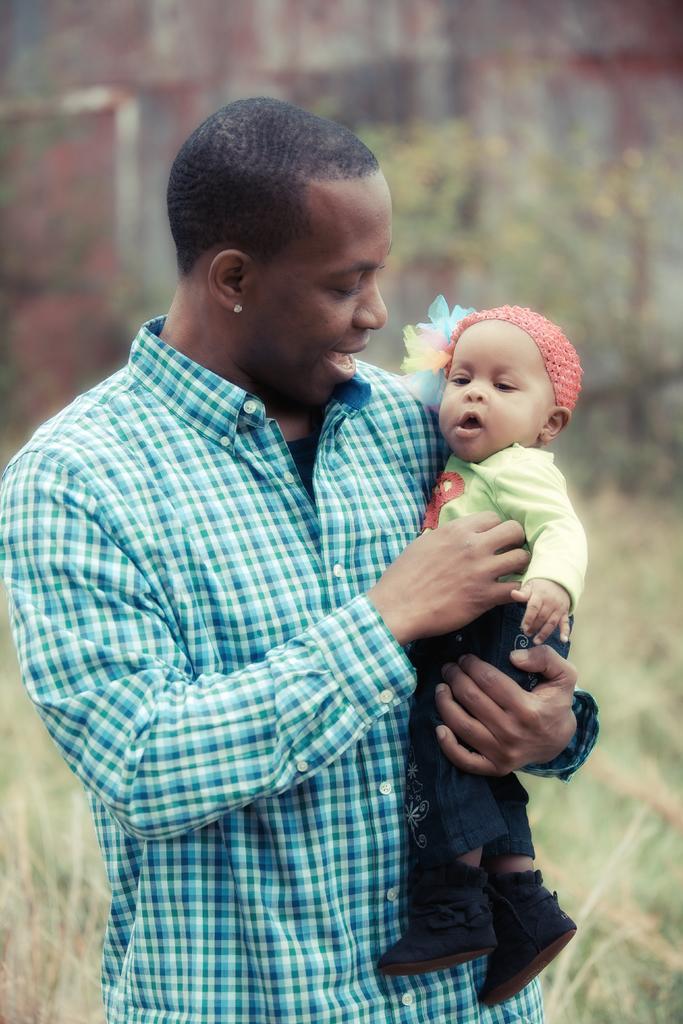Can you describe this image briefly? In this image we can see a man standing holding a child. On the backside we can see some plants and grass. 